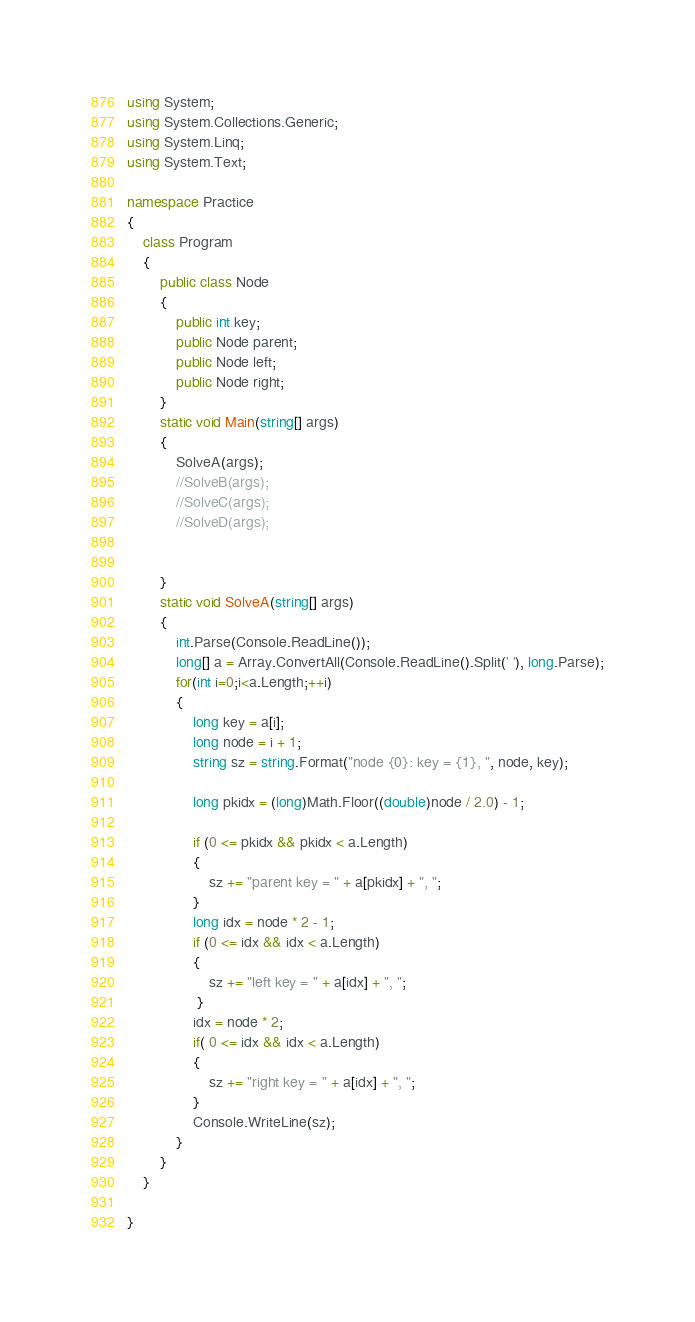<code> <loc_0><loc_0><loc_500><loc_500><_C#_>using System;
using System.Collections.Generic;
using System.Linq;
using System.Text;

namespace Practice
{
    class Program
    {
        public class Node
        {
            public int key;
            public Node parent;
            public Node left;
            public Node right;
        }
        static void Main(string[] args)
        {
            SolveA(args);
            //SolveB(args);
            //SolveC(args);
            //SolveD(args);


        }
        static void SolveA(string[] args)
        {
            int.Parse(Console.ReadLine());
            long[] a = Array.ConvertAll(Console.ReadLine().Split(' '), long.Parse);
            for(int i=0;i<a.Length;++i)
            {
                long key = a[i];
                long node = i + 1;
                string sz = string.Format("node {0}: key = {1}, ", node, key);

                long pkidx = (long)Math.Floor((double)node / 2.0) - 1;

                if (0 <= pkidx && pkidx < a.Length)
                {
                    sz += "parent key = " + a[pkidx] + ", ";
                }
                long idx = node * 2 - 1;
                if (0 <= idx && idx < a.Length)
                {
                    sz += "left key = " + a[idx] + ", ";
                 }
                idx = node * 2;
                if( 0 <= idx && idx < a.Length)
                {
                    sz += "right key = " + a[idx] + ", ";
                }
                Console.WriteLine(sz);
            }
        }
    }

}

</code> 